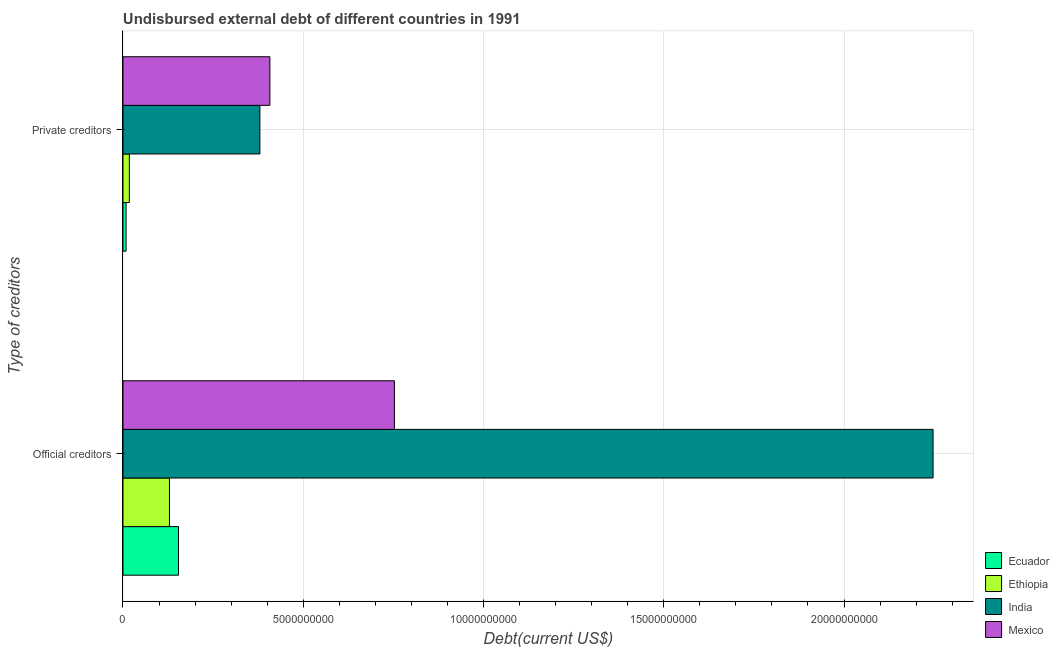How many different coloured bars are there?
Your answer should be compact. 4. How many groups of bars are there?
Ensure brevity in your answer.  2. Are the number of bars per tick equal to the number of legend labels?
Provide a succinct answer. Yes. Are the number of bars on each tick of the Y-axis equal?
Keep it short and to the point. Yes. How many bars are there on the 2nd tick from the top?
Your response must be concise. 4. How many bars are there on the 2nd tick from the bottom?
Offer a terse response. 4. What is the label of the 1st group of bars from the top?
Your response must be concise. Private creditors. What is the undisbursed external debt of private creditors in Mexico?
Your answer should be very brief. 4.07e+09. Across all countries, what is the maximum undisbursed external debt of official creditors?
Your answer should be very brief. 2.25e+1. Across all countries, what is the minimum undisbursed external debt of official creditors?
Keep it short and to the point. 1.29e+09. In which country was the undisbursed external debt of official creditors maximum?
Give a very brief answer. India. In which country was the undisbursed external debt of official creditors minimum?
Your response must be concise. Ethiopia. What is the total undisbursed external debt of official creditors in the graph?
Keep it short and to the point. 3.28e+1. What is the difference between the undisbursed external debt of private creditors in Ethiopia and that in India?
Your answer should be very brief. -3.62e+09. What is the difference between the undisbursed external debt of private creditors in Ethiopia and the undisbursed external debt of official creditors in Ecuador?
Your response must be concise. -1.36e+09. What is the average undisbursed external debt of private creditors per country?
Your answer should be compact. 2.03e+09. What is the difference between the undisbursed external debt of official creditors and undisbursed external debt of private creditors in Mexico?
Offer a very short reply. 3.45e+09. In how many countries, is the undisbursed external debt of private creditors greater than 13000000000 US$?
Offer a very short reply. 0. What is the ratio of the undisbursed external debt of private creditors in Mexico to that in Ecuador?
Keep it short and to the point. 47.46. In how many countries, is the undisbursed external debt of official creditors greater than the average undisbursed external debt of official creditors taken over all countries?
Your response must be concise. 1. What does the 1st bar from the top in Private creditors represents?
Your answer should be compact. Mexico. What does the 1st bar from the bottom in Private creditors represents?
Ensure brevity in your answer.  Ecuador. How many countries are there in the graph?
Your response must be concise. 4. Are the values on the major ticks of X-axis written in scientific E-notation?
Provide a succinct answer. No. Does the graph contain grids?
Offer a terse response. Yes. Where does the legend appear in the graph?
Ensure brevity in your answer.  Bottom right. What is the title of the graph?
Provide a succinct answer. Undisbursed external debt of different countries in 1991. Does "Georgia" appear as one of the legend labels in the graph?
Your answer should be very brief. No. What is the label or title of the X-axis?
Your answer should be very brief. Debt(current US$). What is the label or title of the Y-axis?
Your answer should be compact. Type of creditors. What is the Debt(current US$) in Ecuador in Official creditors?
Your answer should be very brief. 1.54e+09. What is the Debt(current US$) in Ethiopia in Official creditors?
Your response must be concise. 1.29e+09. What is the Debt(current US$) of India in Official creditors?
Ensure brevity in your answer.  2.25e+1. What is the Debt(current US$) of Mexico in Official creditors?
Make the answer very short. 7.53e+09. What is the Debt(current US$) of Ecuador in Private creditors?
Offer a very short reply. 8.59e+07. What is the Debt(current US$) of Ethiopia in Private creditors?
Your answer should be very brief. 1.76e+08. What is the Debt(current US$) of India in Private creditors?
Your response must be concise. 3.80e+09. What is the Debt(current US$) of Mexico in Private creditors?
Provide a succinct answer. 4.07e+09. Across all Type of creditors, what is the maximum Debt(current US$) of Ecuador?
Your answer should be compact. 1.54e+09. Across all Type of creditors, what is the maximum Debt(current US$) in Ethiopia?
Give a very brief answer. 1.29e+09. Across all Type of creditors, what is the maximum Debt(current US$) of India?
Make the answer very short. 2.25e+1. Across all Type of creditors, what is the maximum Debt(current US$) of Mexico?
Ensure brevity in your answer.  7.53e+09. Across all Type of creditors, what is the minimum Debt(current US$) in Ecuador?
Your answer should be compact. 8.59e+07. Across all Type of creditors, what is the minimum Debt(current US$) of Ethiopia?
Offer a very short reply. 1.76e+08. Across all Type of creditors, what is the minimum Debt(current US$) in India?
Your answer should be very brief. 3.80e+09. Across all Type of creditors, what is the minimum Debt(current US$) of Mexico?
Provide a short and direct response. 4.07e+09. What is the total Debt(current US$) in Ecuador in the graph?
Ensure brevity in your answer.  1.63e+09. What is the total Debt(current US$) in Ethiopia in the graph?
Provide a succinct answer. 1.47e+09. What is the total Debt(current US$) of India in the graph?
Your answer should be compact. 2.63e+1. What is the total Debt(current US$) in Mexico in the graph?
Your answer should be very brief. 1.16e+1. What is the difference between the Debt(current US$) in Ecuador in Official creditors and that in Private creditors?
Your answer should be compact. 1.45e+09. What is the difference between the Debt(current US$) in Ethiopia in Official creditors and that in Private creditors?
Your answer should be very brief. 1.11e+09. What is the difference between the Debt(current US$) of India in Official creditors and that in Private creditors?
Your answer should be very brief. 1.87e+1. What is the difference between the Debt(current US$) of Mexico in Official creditors and that in Private creditors?
Offer a very short reply. 3.45e+09. What is the difference between the Debt(current US$) of Ecuador in Official creditors and the Debt(current US$) of Ethiopia in Private creditors?
Your answer should be very brief. 1.36e+09. What is the difference between the Debt(current US$) in Ecuador in Official creditors and the Debt(current US$) in India in Private creditors?
Your response must be concise. -2.26e+09. What is the difference between the Debt(current US$) of Ecuador in Official creditors and the Debt(current US$) of Mexico in Private creditors?
Your answer should be compact. -2.53e+09. What is the difference between the Debt(current US$) of Ethiopia in Official creditors and the Debt(current US$) of India in Private creditors?
Give a very brief answer. -2.51e+09. What is the difference between the Debt(current US$) in Ethiopia in Official creditors and the Debt(current US$) in Mexico in Private creditors?
Make the answer very short. -2.79e+09. What is the difference between the Debt(current US$) in India in Official creditors and the Debt(current US$) in Mexico in Private creditors?
Your answer should be very brief. 1.84e+1. What is the average Debt(current US$) in Ecuador per Type of creditors?
Make the answer very short. 8.13e+08. What is the average Debt(current US$) of Ethiopia per Type of creditors?
Ensure brevity in your answer.  7.33e+08. What is the average Debt(current US$) in India per Type of creditors?
Offer a terse response. 1.31e+1. What is the average Debt(current US$) in Mexico per Type of creditors?
Provide a short and direct response. 5.80e+09. What is the difference between the Debt(current US$) in Ecuador and Debt(current US$) in Ethiopia in Official creditors?
Your answer should be very brief. 2.51e+08. What is the difference between the Debt(current US$) of Ecuador and Debt(current US$) of India in Official creditors?
Provide a short and direct response. -2.09e+1. What is the difference between the Debt(current US$) in Ecuador and Debt(current US$) in Mexico in Official creditors?
Your answer should be compact. -5.99e+09. What is the difference between the Debt(current US$) in Ethiopia and Debt(current US$) in India in Official creditors?
Offer a very short reply. -2.12e+1. What is the difference between the Debt(current US$) of Ethiopia and Debt(current US$) of Mexico in Official creditors?
Your response must be concise. -6.24e+09. What is the difference between the Debt(current US$) in India and Debt(current US$) in Mexico in Official creditors?
Offer a very short reply. 1.49e+1. What is the difference between the Debt(current US$) in Ecuador and Debt(current US$) in Ethiopia in Private creditors?
Your response must be concise. -9.04e+07. What is the difference between the Debt(current US$) of Ecuador and Debt(current US$) of India in Private creditors?
Your response must be concise. -3.71e+09. What is the difference between the Debt(current US$) of Ecuador and Debt(current US$) of Mexico in Private creditors?
Provide a succinct answer. -3.99e+09. What is the difference between the Debt(current US$) in Ethiopia and Debt(current US$) in India in Private creditors?
Your answer should be very brief. -3.62e+09. What is the difference between the Debt(current US$) of Ethiopia and Debt(current US$) of Mexico in Private creditors?
Offer a very short reply. -3.90e+09. What is the difference between the Debt(current US$) of India and Debt(current US$) of Mexico in Private creditors?
Provide a succinct answer. -2.77e+08. What is the ratio of the Debt(current US$) of Ecuador in Official creditors to that in Private creditors?
Keep it short and to the point. 17.94. What is the ratio of the Debt(current US$) in Ethiopia in Official creditors to that in Private creditors?
Your response must be concise. 7.31. What is the ratio of the Debt(current US$) in India in Official creditors to that in Private creditors?
Your answer should be compact. 5.92. What is the ratio of the Debt(current US$) in Mexico in Official creditors to that in Private creditors?
Ensure brevity in your answer.  1.85. What is the difference between the highest and the second highest Debt(current US$) of Ecuador?
Your answer should be very brief. 1.45e+09. What is the difference between the highest and the second highest Debt(current US$) in Ethiopia?
Give a very brief answer. 1.11e+09. What is the difference between the highest and the second highest Debt(current US$) in India?
Your answer should be compact. 1.87e+1. What is the difference between the highest and the second highest Debt(current US$) of Mexico?
Offer a very short reply. 3.45e+09. What is the difference between the highest and the lowest Debt(current US$) of Ecuador?
Make the answer very short. 1.45e+09. What is the difference between the highest and the lowest Debt(current US$) of Ethiopia?
Ensure brevity in your answer.  1.11e+09. What is the difference between the highest and the lowest Debt(current US$) of India?
Provide a short and direct response. 1.87e+1. What is the difference between the highest and the lowest Debt(current US$) of Mexico?
Your response must be concise. 3.45e+09. 